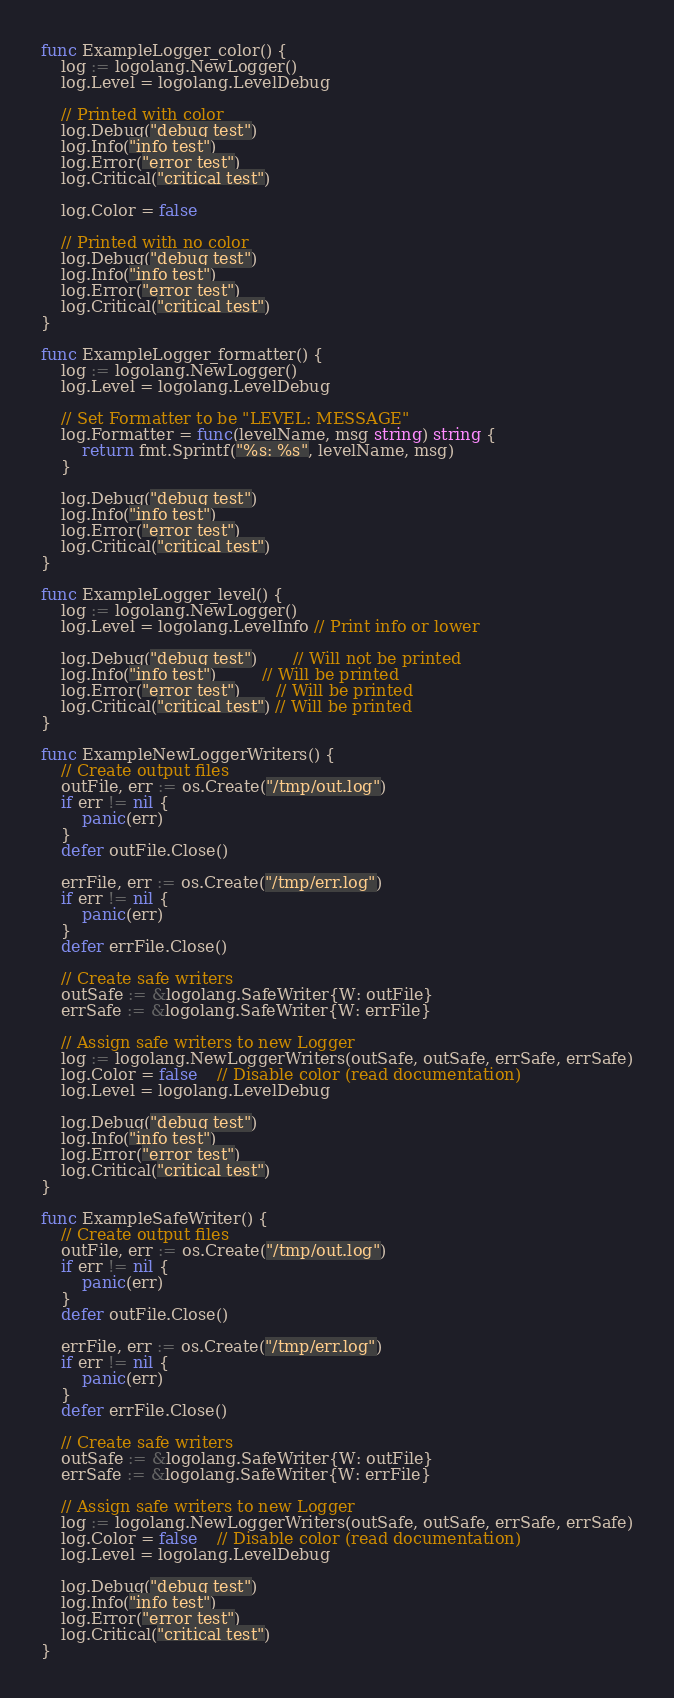<code> <loc_0><loc_0><loc_500><loc_500><_Go_>func ExampleLogger_color() {
	log := logolang.NewLogger()
	log.Level = logolang.LevelDebug

	// Printed with color
	log.Debug("debug test")
	log.Info("info test")
	log.Error("error test")
	log.Critical("critical test")

	log.Color = false

	// Printed with no color
	log.Debug("debug test")
	log.Info("info test")
	log.Error("error test")
	log.Critical("critical test")
}

func ExampleLogger_formatter() {
	log := logolang.NewLogger()
	log.Level = logolang.LevelDebug

	// Set Formatter to be "LEVEL: MESSAGE"
	log.Formatter = func(levelName, msg string) string {
		return fmt.Sprintf("%s: %s", levelName, msg)
	}

	log.Debug("debug test")
	log.Info("info test")
	log.Error("error test")
	log.Critical("critical test")
}

func ExampleLogger_level() {
	log := logolang.NewLogger()
	log.Level = logolang.LevelInfo // Print info or lower

	log.Debug("debug test")       // Will not be printed
	log.Info("info test")         // Will be printed
	log.Error("error test")       // Will be printed
	log.Critical("critical test") // Will be printed
}

func ExampleNewLoggerWriters() {
	// Create output files
	outFile, err := os.Create("/tmp/out.log")
	if err != nil {
		panic(err)
	}
	defer outFile.Close()

	errFile, err := os.Create("/tmp/err.log")
	if err != nil {
		panic(err)
	}
	defer errFile.Close()

	// Create safe writers
	outSafe := &logolang.SafeWriter{W: outFile}
	errSafe := &logolang.SafeWriter{W: errFile}

	// Assign safe writers to new Logger
	log := logolang.NewLoggerWriters(outSafe, outSafe, errSafe, errSafe)
	log.Color = false    // Disable color (read documentation)
	log.Level = logolang.LevelDebug

	log.Debug("debug test")
	log.Info("info test")
	log.Error("error test")
	log.Critical("critical test")
}

func ExampleSafeWriter() {
	// Create output files
	outFile, err := os.Create("/tmp/out.log")
	if err != nil {
		panic(err)
	}
	defer outFile.Close()

	errFile, err := os.Create("/tmp/err.log")
	if err != nil {
		panic(err)
	}
	defer errFile.Close()

	// Create safe writers
	outSafe := &logolang.SafeWriter{W: outFile}
	errSafe := &logolang.SafeWriter{W: errFile}

	// Assign safe writers to new Logger
	log := logolang.NewLoggerWriters(outSafe, outSafe, errSafe, errSafe)
	log.Color = false    // Disable color (read documentation)
	log.Level = logolang.LevelDebug

	log.Debug("debug test")
	log.Info("info test")
	log.Error("error test")
	log.Critical("critical test")
}
</code> 